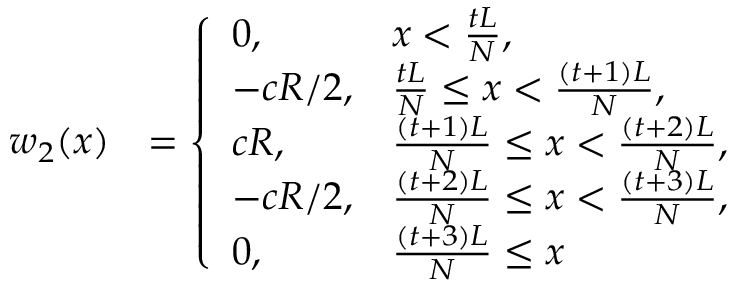<formula> <loc_0><loc_0><loc_500><loc_500>\begin{array} { r l } { w _ { 2 } ( x ) } & { = \left \{ \begin{array} { l l } { 0 , } & { x < \frac { t L } { N } , } \\ { - c R / 2 , } & { \frac { t L } { N } \leq x < \frac { ( t + 1 ) L } { N } , } \\ { c R , } & { \frac { ( t + 1 ) L } { N } \leq x < \frac { ( t + 2 ) L } { N } , } \\ { - c R / 2 , } & { \frac { ( t + 2 ) L } { N } \leq x < \frac { ( t + 3 ) L } { N } , } \\ { 0 , } & { \frac { ( t + 3 ) L } { N } \leq x } \end{array} } \end{array}</formula> 